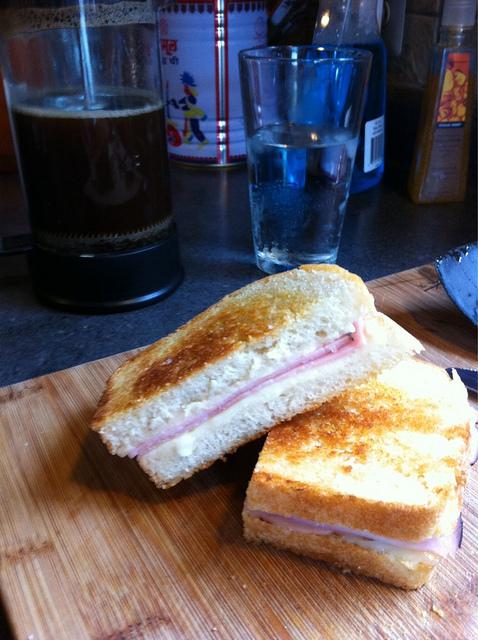What is the name of the container in the background holding coffee?

Choices:
A) aeropress coffee
B) french press
C) drip machine
D) coffee maker french press 